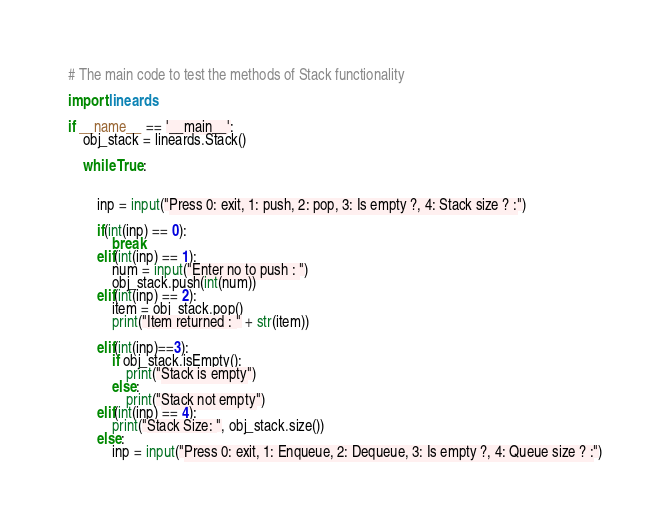Convert code to text. <code><loc_0><loc_0><loc_500><loc_500><_Python_># The main code to test the methods of Stack functionality

import lineards

if __name__ == '__main__':
    obj_stack = lineards.Stack()
    
    while True:
        
        
        inp = input("Press 0: exit, 1: push, 2: pop, 3: Is empty ?, 4: Stack size ? :")

        if(int(inp) == 0):
            break
        elif(int(inp) == 1):
            num = input("Enter no to push : ")
            obj_stack.push(int(num))
        elif(int(inp) == 2):
            item = obj_stack.pop()
            print("Item returned : " + str(item))

        elif(int(inp)==3):
            if obj_stack.isEmpty():
                print("Stack is empty")
            else:
                print("Stack not empty")
        elif(int(inp) == 4):
            print("Stack Size: ", obj_stack.size())    
        else:
            inp = input("Press 0: exit, 1: Enqueue, 2: Dequeue, 3: Is empty ?, 4: Queue size ? :")</code> 